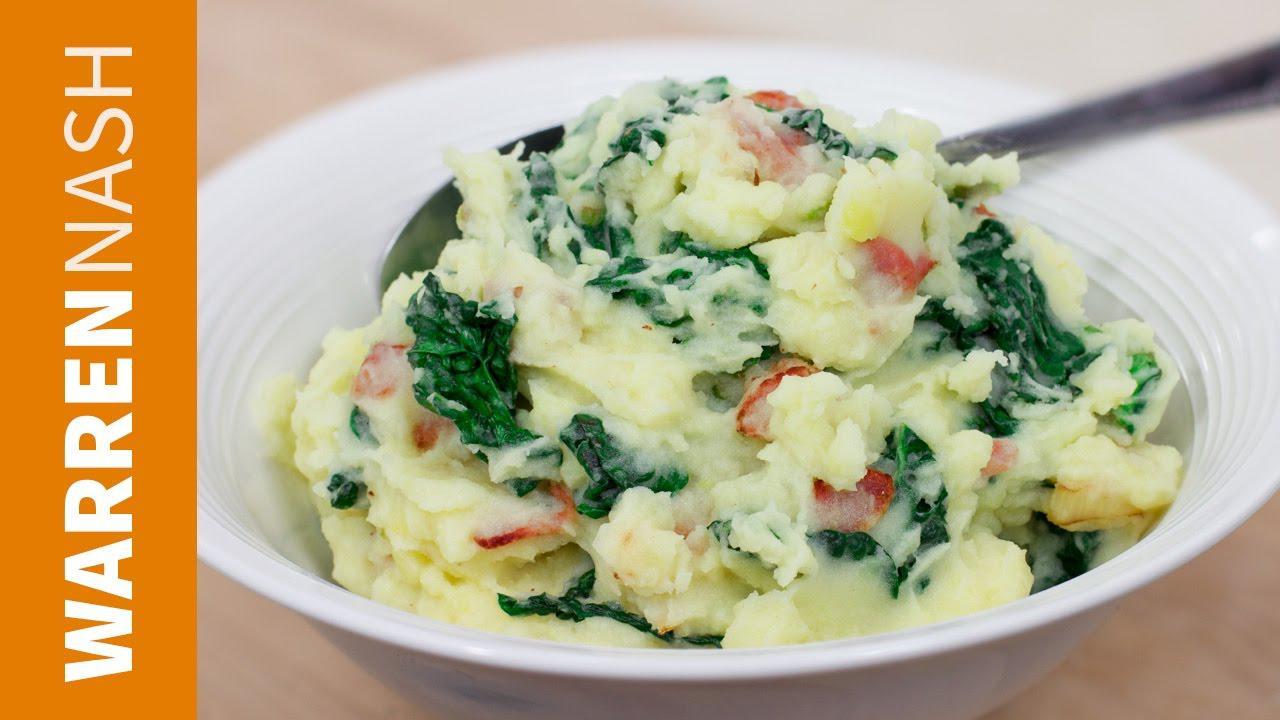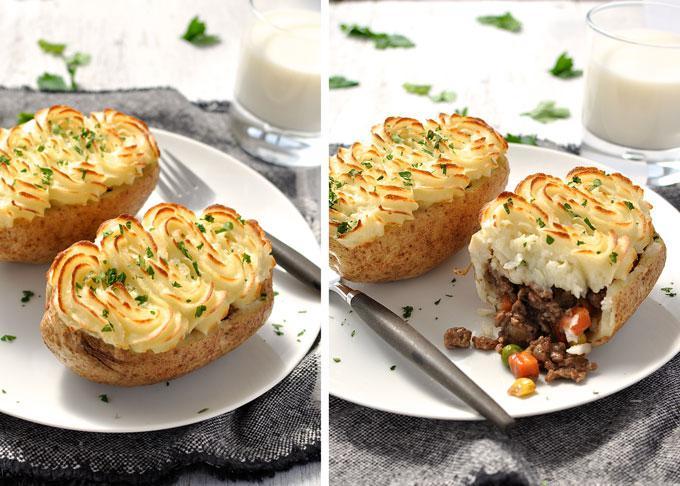The first image is the image on the left, the second image is the image on the right. Evaluate the accuracy of this statement regarding the images: "There are three bowls in the left image.". Is it true? Answer yes or no. No. The first image is the image on the left, the second image is the image on the right. Examine the images to the left and right. Is the description "All images include an item of silverware by a prepared potato dish." accurate? Answer yes or no. Yes. 